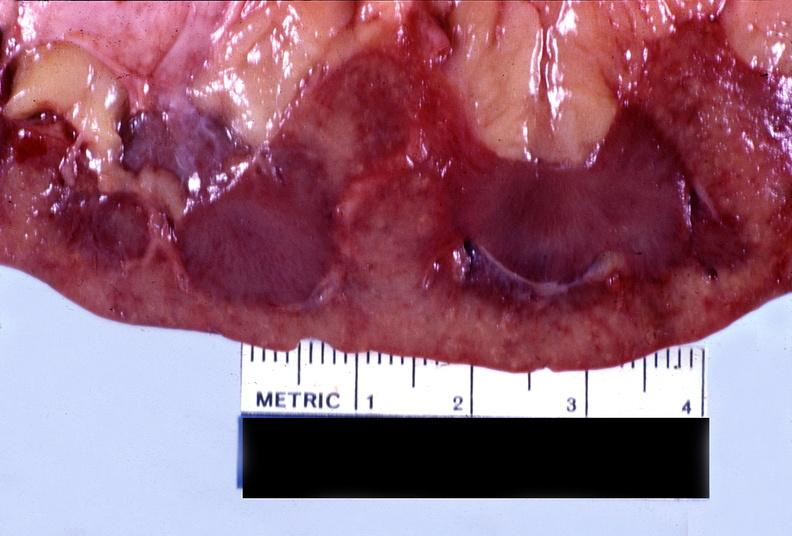does this image show kidney, malignant, nephrosclerosis?
Answer the question using a single word or phrase. Yes 